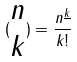<formula> <loc_0><loc_0><loc_500><loc_500>( \begin{matrix} n \\ k \end{matrix} ) = \frac { n ^ { \underline { k } } } { k ! }</formula> 